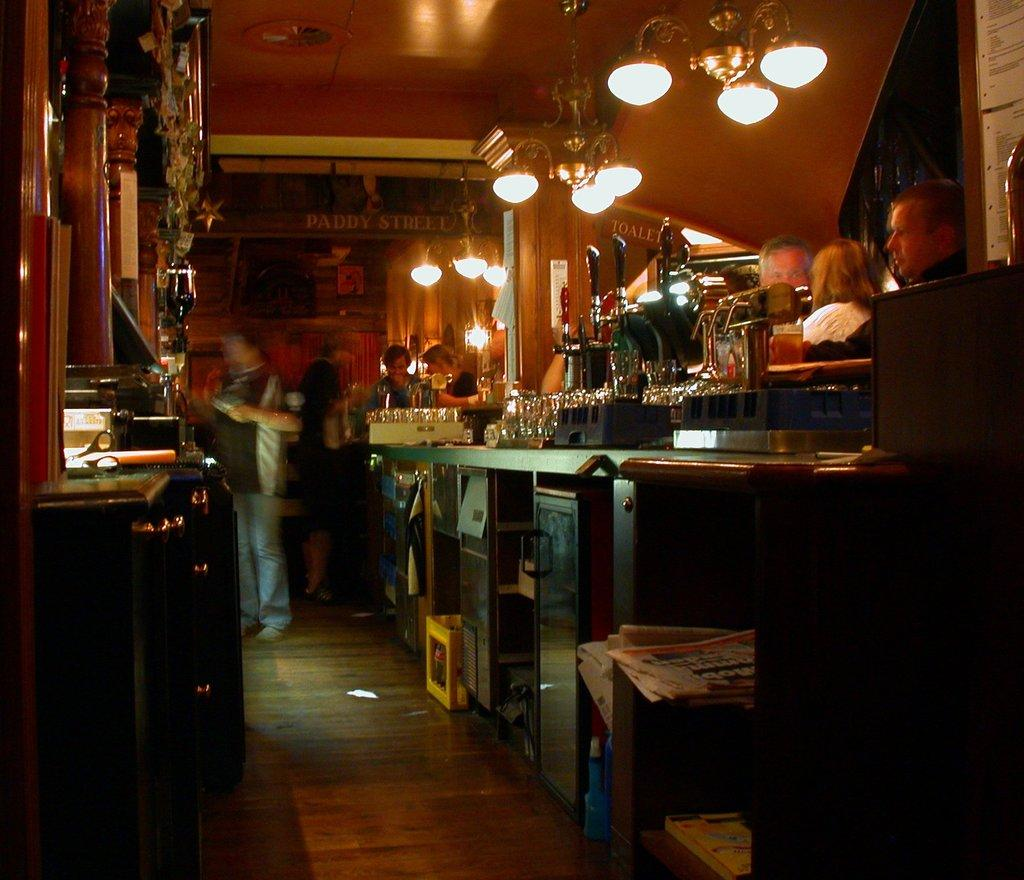What type of furniture can be seen in the image? There are cabinets in the image. What type of tool is present in the image? There are scissors in the image. Can you describe the people in the image? There are people standing in the image. What type of dishware is visible in the image? There are glasses in the image. What type of illumination is present in the image? There are lights in the image. What part of the room is visible in the image? The ceiling is visible in the image. What type of reading material is present in the image? There are books in the image. What part of the room's surface is visible in the image? The floor is visible in the image. What other objects can be seen in the image? There are other objects in the image. How many yaks are present in the image? There are no yaks present in the image. What type of drawer is visible in the image? There is no drawer present in the image. 